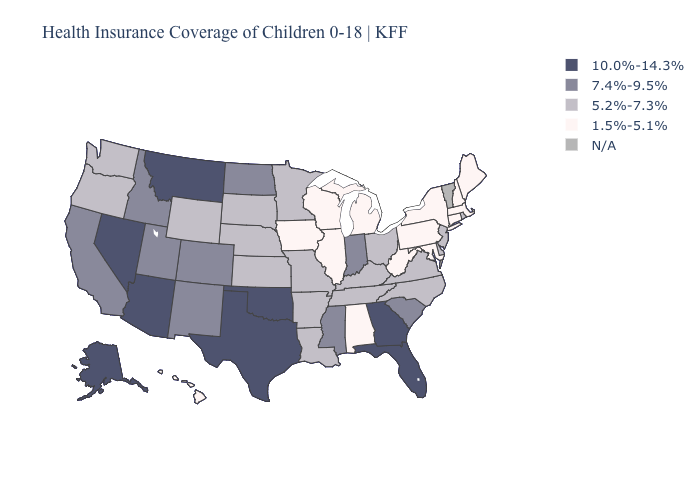Does Washington have the lowest value in the USA?
Write a very short answer. No. Name the states that have a value in the range N/A?
Write a very short answer. Vermont. Name the states that have a value in the range 10.0%-14.3%?
Be succinct. Alaska, Arizona, Florida, Georgia, Montana, Nevada, Oklahoma, Texas. Which states hav the highest value in the West?
Quick response, please. Alaska, Arizona, Montana, Nevada. What is the lowest value in the USA?
Concise answer only. 1.5%-5.1%. Does Hawaii have the lowest value in the West?
Keep it brief. Yes. What is the value of Arkansas?
Give a very brief answer. 5.2%-7.3%. What is the value of Ohio?
Short answer required. 5.2%-7.3%. What is the value of Kentucky?
Keep it brief. 5.2%-7.3%. Among the states that border Tennessee , which have the lowest value?
Quick response, please. Alabama. Which states have the highest value in the USA?
Short answer required. Alaska, Arizona, Florida, Georgia, Montana, Nevada, Oklahoma, Texas. Name the states that have a value in the range 10.0%-14.3%?
Concise answer only. Alaska, Arizona, Florida, Georgia, Montana, Nevada, Oklahoma, Texas. Among the states that border Rhode Island , which have the highest value?
Concise answer only. Connecticut, Massachusetts. Among the states that border Minnesota , does South Dakota have the lowest value?
Concise answer only. No. 